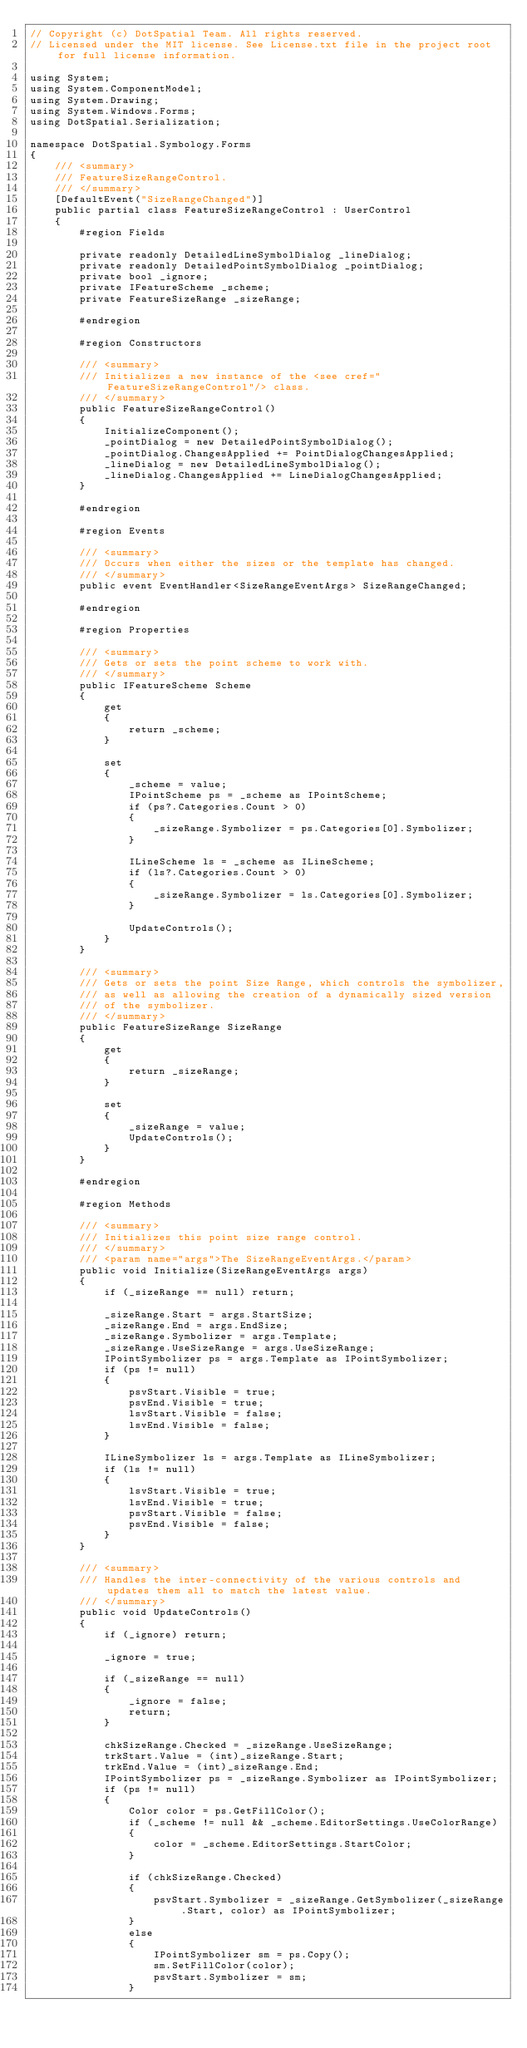Convert code to text. <code><loc_0><loc_0><loc_500><loc_500><_C#_>// Copyright (c) DotSpatial Team. All rights reserved.
// Licensed under the MIT license. See License.txt file in the project root for full license information.

using System;
using System.ComponentModel;
using System.Drawing;
using System.Windows.Forms;
using DotSpatial.Serialization;

namespace DotSpatial.Symbology.Forms
{
    /// <summary>
    /// FeatureSizeRangeControl.
    /// </summary>
    [DefaultEvent("SizeRangeChanged")]
    public partial class FeatureSizeRangeControl : UserControl
    {
        #region Fields

        private readonly DetailedLineSymbolDialog _lineDialog;
        private readonly DetailedPointSymbolDialog _pointDialog;
        private bool _ignore;
        private IFeatureScheme _scheme;
        private FeatureSizeRange _sizeRange;

        #endregion

        #region Constructors

        /// <summary>
        /// Initializes a new instance of the <see cref="FeatureSizeRangeControl"/> class.
        /// </summary>
        public FeatureSizeRangeControl()
        {
            InitializeComponent();
            _pointDialog = new DetailedPointSymbolDialog();
            _pointDialog.ChangesApplied += PointDialogChangesApplied;
            _lineDialog = new DetailedLineSymbolDialog();
            _lineDialog.ChangesApplied += LineDialogChangesApplied;
        }

        #endregion

        #region Events

        /// <summary>
        /// Occurs when either the sizes or the template has changed.
        /// </summary>
        public event EventHandler<SizeRangeEventArgs> SizeRangeChanged;

        #endregion

        #region Properties

        /// <summary>
        /// Gets or sets the point scheme to work with.
        /// </summary>
        public IFeatureScheme Scheme
        {
            get
            {
                return _scheme;
            }

            set
            {
                _scheme = value;
                IPointScheme ps = _scheme as IPointScheme;
                if (ps?.Categories.Count > 0)
                {
                    _sizeRange.Symbolizer = ps.Categories[0].Symbolizer;
                }

                ILineScheme ls = _scheme as ILineScheme;
                if (ls?.Categories.Count > 0)
                {
                    _sizeRange.Symbolizer = ls.Categories[0].Symbolizer;
                }

                UpdateControls();
            }
        }

        /// <summary>
        /// Gets or sets the point Size Range, which controls the symbolizer,
        /// as well as allowing the creation of a dynamically sized version
        /// of the symbolizer.
        /// </summary>
        public FeatureSizeRange SizeRange
        {
            get
            {
                return _sizeRange;
            }

            set
            {
                _sizeRange = value;
                UpdateControls();
            }
        }

        #endregion

        #region Methods

        /// <summary>
        /// Initializes this point size range control.
        /// </summary>
        /// <param name="args">The SizeRangeEventArgs.</param>
        public void Initialize(SizeRangeEventArgs args)
        {
            if (_sizeRange == null) return;

            _sizeRange.Start = args.StartSize;
            _sizeRange.End = args.EndSize;
            _sizeRange.Symbolizer = args.Template;
            _sizeRange.UseSizeRange = args.UseSizeRange;
            IPointSymbolizer ps = args.Template as IPointSymbolizer;
            if (ps != null)
            {
                psvStart.Visible = true;
                psvEnd.Visible = true;
                lsvStart.Visible = false;
                lsvEnd.Visible = false;
            }

            ILineSymbolizer ls = args.Template as ILineSymbolizer;
            if (ls != null)
            {
                lsvStart.Visible = true;
                lsvEnd.Visible = true;
                psvStart.Visible = false;
                psvEnd.Visible = false;
            }
        }

        /// <summary>
        /// Handles the inter-connectivity of the various controls and updates them all to match the latest value.
        /// </summary>
        public void UpdateControls()
        {
            if (_ignore) return;

            _ignore = true;

            if (_sizeRange == null)
            {
                _ignore = false;
                return;
            }

            chkSizeRange.Checked = _sizeRange.UseSizeRange;
            trkStart.Value = (int)_sizeRange.Start;
            trkEnd.Value = (int)_sizeRange.End;
            IPointSymbolizer ps = _sizeRange.Symbolizer as IPointSymbolizer;
            if (ps != null)
            {
                Color color = ps.GetFillColor();
                if (_scheme != null && _scheme.EditorSettings.UseColorRange)
                {
                    color = _scheme.EditorSettings.StartColor;
                }

                if (chkSizeRange.Checked)
                {
                    psvStart.Symbolizer = _sizeRange.GetSymbolizer(_sizeRange.Start, color) as IPointSymbolizer;
                }
                else
                {
                    IPointSymbolizer sm = ps.Copy();
                    sm.SetFillColor(color);
                    psvStart.Symbolizer = sm;
                }
</code> 